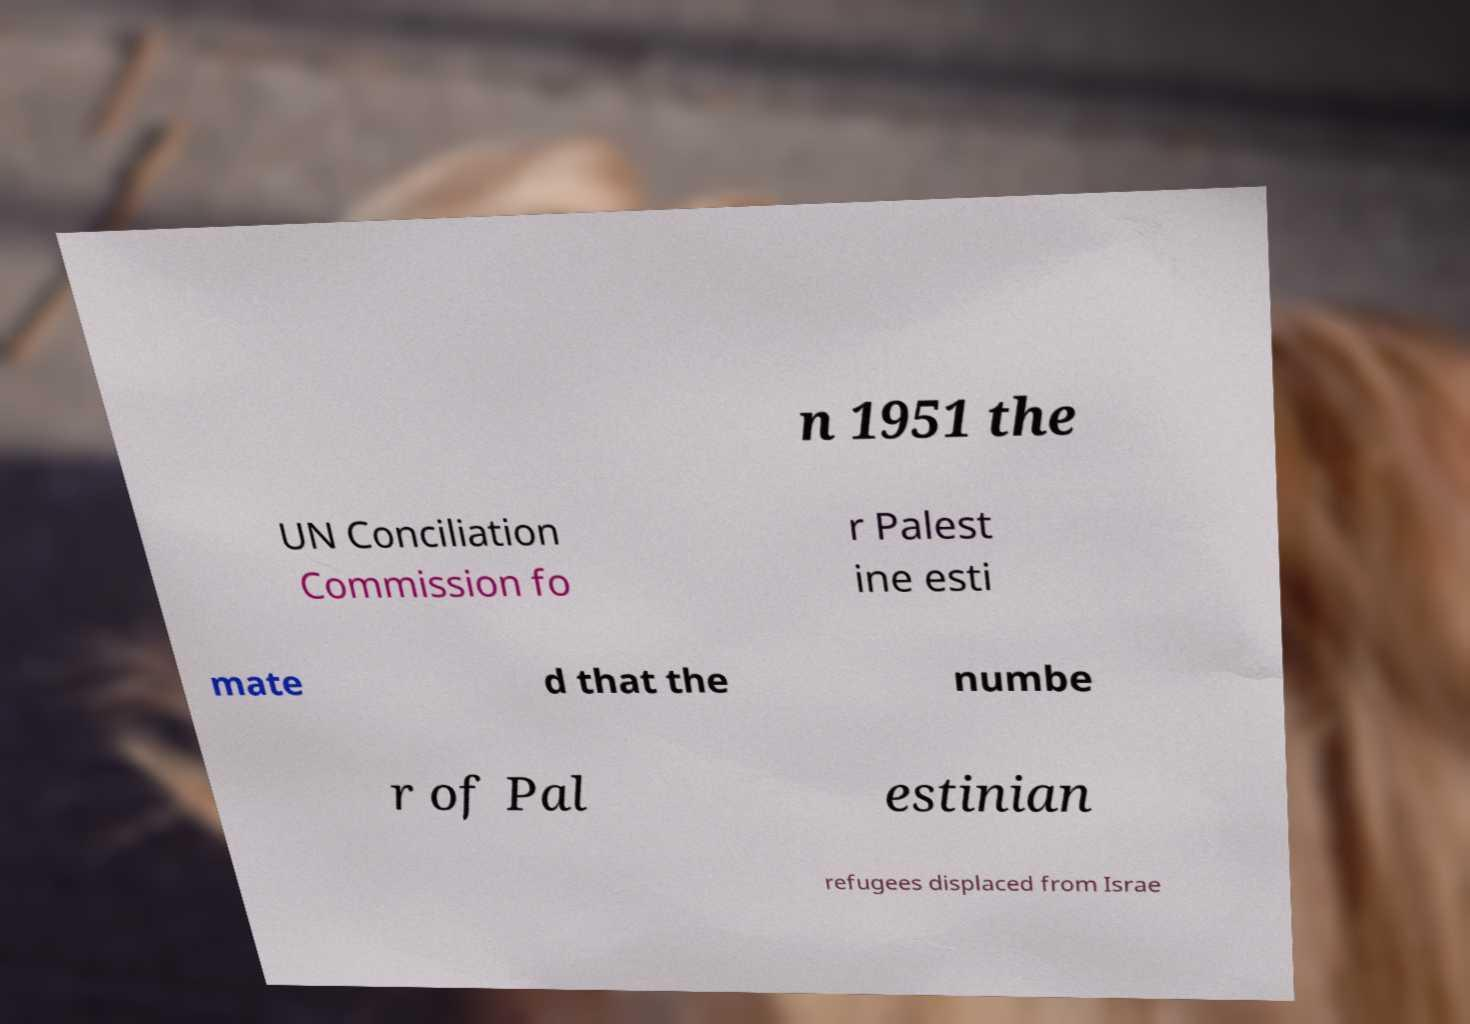Can you accurately transcribe the text from the provided image for me? n 1951 the UN Conciliation Commission fo r Palest ine esti mate d that the numbe r of Pal estinian refugees displaced from Israe 